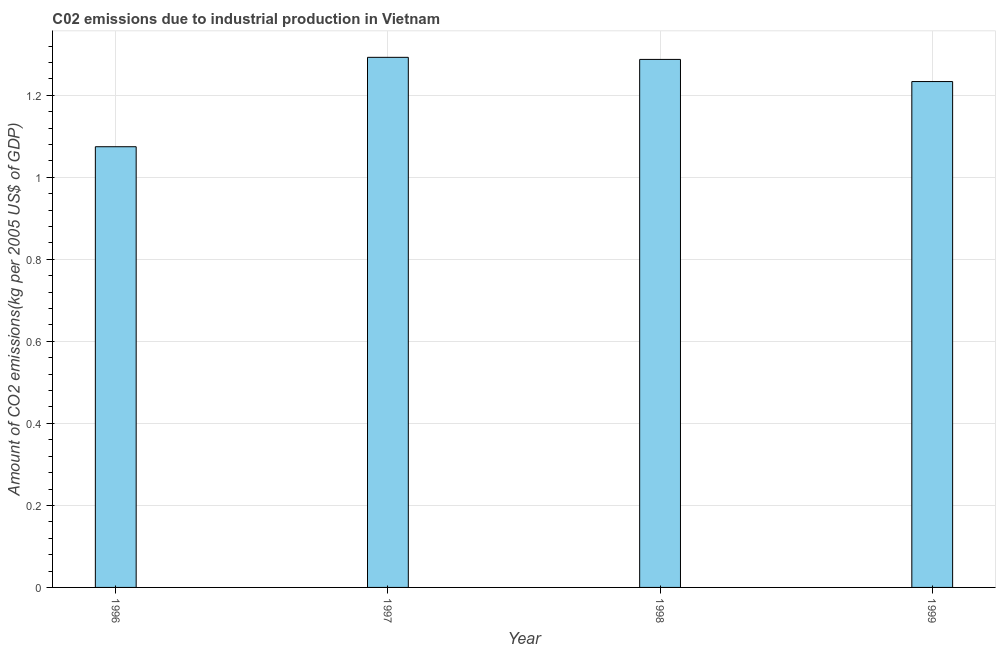What is the title of the graph?
Give a very brief answer. C02 emissions due to industrial production in Vietnam. What is the label or title of the Y-axis?
Your response must be concise. Amount of CO2 emissions(kg per 2005 US$ of GDP). What is the amount of co2 emissions in 1998?
Offer a terse response. 1.29. Across all years, what is the maximum amount of co2 emissions?
Offer a very short reply. 1.29. Across all years, what is the minimum amount of co2 emissions?
Give a very brief answer. 1.07. In which year was the amount of co2 emissions maximum?
Give a very brief answer. 1997. What is the sum of the amount of co2 emissions?
Your answer should be very brief. 4.89. What is the difference between the amount of co2 emissions in 1997 and 1999?
Give a very brief answer. 0.06. What is the average amount of co2 emissions per year?
Your response must be concise. 1.22. What is the median amount of co2 emissions?
Offer a very short reply. 1.26. In how many years, is the amount of co2 emissions greater than 0.56 kg per 2005 US$ of GDP?
Your answer should be very brief. 4. What is the ratio of the amount of co2 emissions in 1996 to that in 1997?
Provide a short and direct response. 0.83. Is the difference between the amount of co2 emissions in 1998 and 1999 greater than the difference between any two years?
Provide a succinct answer. No. What is the difference between the highest and the second highest amount of co2 emissions?
Ensure brevity in your answer.  0.01. Is the sum of the amount of co2 emissions in 1996 and 1997 greater than the maximum amount of co2 emissions across all years?
Your response must be concise. Yes. What is the difference between the highest and the lowest amount of co2 emissions?
Your answer should be compact. 0.22. Are all the bars in the graph horizontal?
Your answer should be compact. No. How many years are there in the graph?
Give a very brief answer. 4. What is the difference between two consecutive major ticks on the Y-axis?
Your answer should be very brief. 0.2. What is the Amount of CO2 emissions(kg per 2005 US$ of GDP) in 1996?
Give a very brief answer. 1.07. What is the Amount of CO2 emissions(kg per 2005 US$ of GDP) in 1997?
Ensure brevity in your answer.  1.29. What is the Amount of CO2 emissions(kg per 2005 US$ of GDP) of 1998?
Offer a very short reply. 1.29. What is the Amount of CO2 emissions(kg per 2005 US$ of GDP) in 1999?
Ensure brevity in your answer.  1.23. What is the difference between the Amount of CO2 emissions(kg per 2005 US$ of GDP) in 1996 and 1997?
Your response must be concise. -0.22. What is the difference between the Amount of CO2 emissions(kg per 2005 US$ of GDP) in 1996 and 1998?
Your response must be concise. -0.21. What is the difference between the Amount of CO2 emissions(kg per 2005 US$ of GDP) in 1996 and 1999?
Offer a very short reply. -0.16. What is the difference between the Amount of CO2 emissions(kg per 2005 US$ of GDP) in 1997 and 1998?
Offer a very short reply. 0.01. What is the difference between the Amount of CO2 emissions(kg per 2005 US$ of GDP) in 1997 and 1999?
Offer a terse response. 0.06. What is the difference between the Amount of CO2 emissions(kg per 2005 US$ of GDP) in 1998 and 1999?
Keep it short and to the point. 0.05. What is the ratio of the Amount of CO2 emissions(kg per 2005 US$ of GDP) in 1996 to that in 1997?
Give a very brief answer. 0.83. What is the ratio of the Amount of CO2 emissions(kg per 2005 US$ of GDP) in 1996 to that in 1998?
Keep it short and to the point. 0.83. What is the ratio of the Amount of CO2 emissions(kg per 2005 US$ of GDP) in 1996 to that in 1999?
Your response must be concise. 0.87. What is the ratio of the Amount of CO2 emissions(kg per 2005 US$ of GDP) in 1997 to that in 1998?
Make the answer very short. 1. What is the ratio of the Amount of CO2 emissions(kg per 2005 US$ of GDP) in 1997 to that in 1999?
Offer a very short reply. 1.05. What is the ratio of the Amount of CO2 emissions(kg per 2005 US$ of GDP) in 1998 to that in 1999?
Your answer should be very brief. 1.04. 